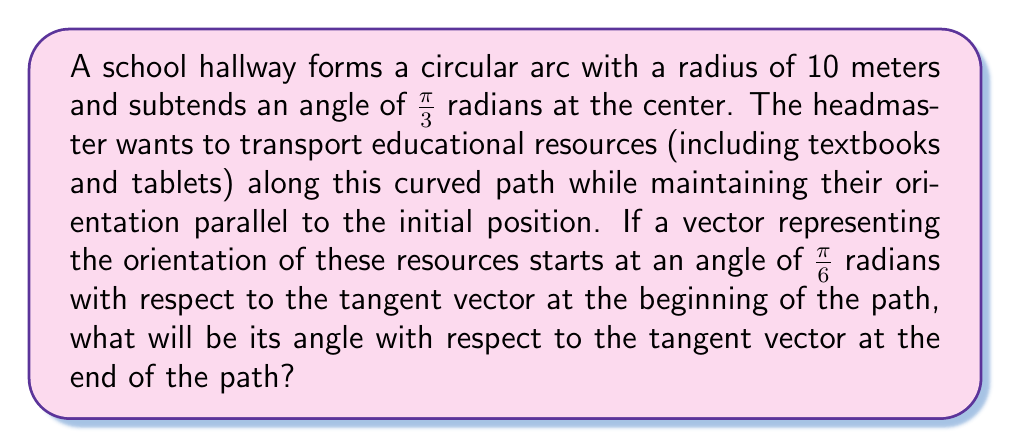Can you answer this question? To solve this problem, we'll use the concept of parallel transport along a curved surface. In this case, the surface is a circular arc.

Step 1: Understand the setup
- The hallway forms a circular arc with radius $R = 10$ meters
- The arc subtends an angle $\theta = \frac{\pi}{3}$ radians at the center
- The initial angle of the vector with respect to the tangent is $\alpha = \frac{\pi}{6}$ radians

Step 2: Calculate the parallel transport
For a circular path, the angle between the transported vector and the tangent vector changes by the same amount as the angle subtended at the center, but in the opposite direction.

Step 3: Determine the final angle
The change in angle is $-\theta = -\frac{\pi}{3}$ radians
The final angle $\beta$ with respect to the tangent vector is:

$$\beta = \alpha - \theta = \frac{\pi}{6} - \frac{\pi}{3} = -\frac{\pi}{6}$$

Step 4: Interpret the result
The negative angle means the vector has rotated clockwise with respect to the tangent vector. In absolute terms, this is equivalent to an angle of $\frac{\pi}{6}$ radians in the opposite direction.
Answer: $-\frac{\pi}{6}$ radians or $\frac{\pi}{6}$ radians clockwise 